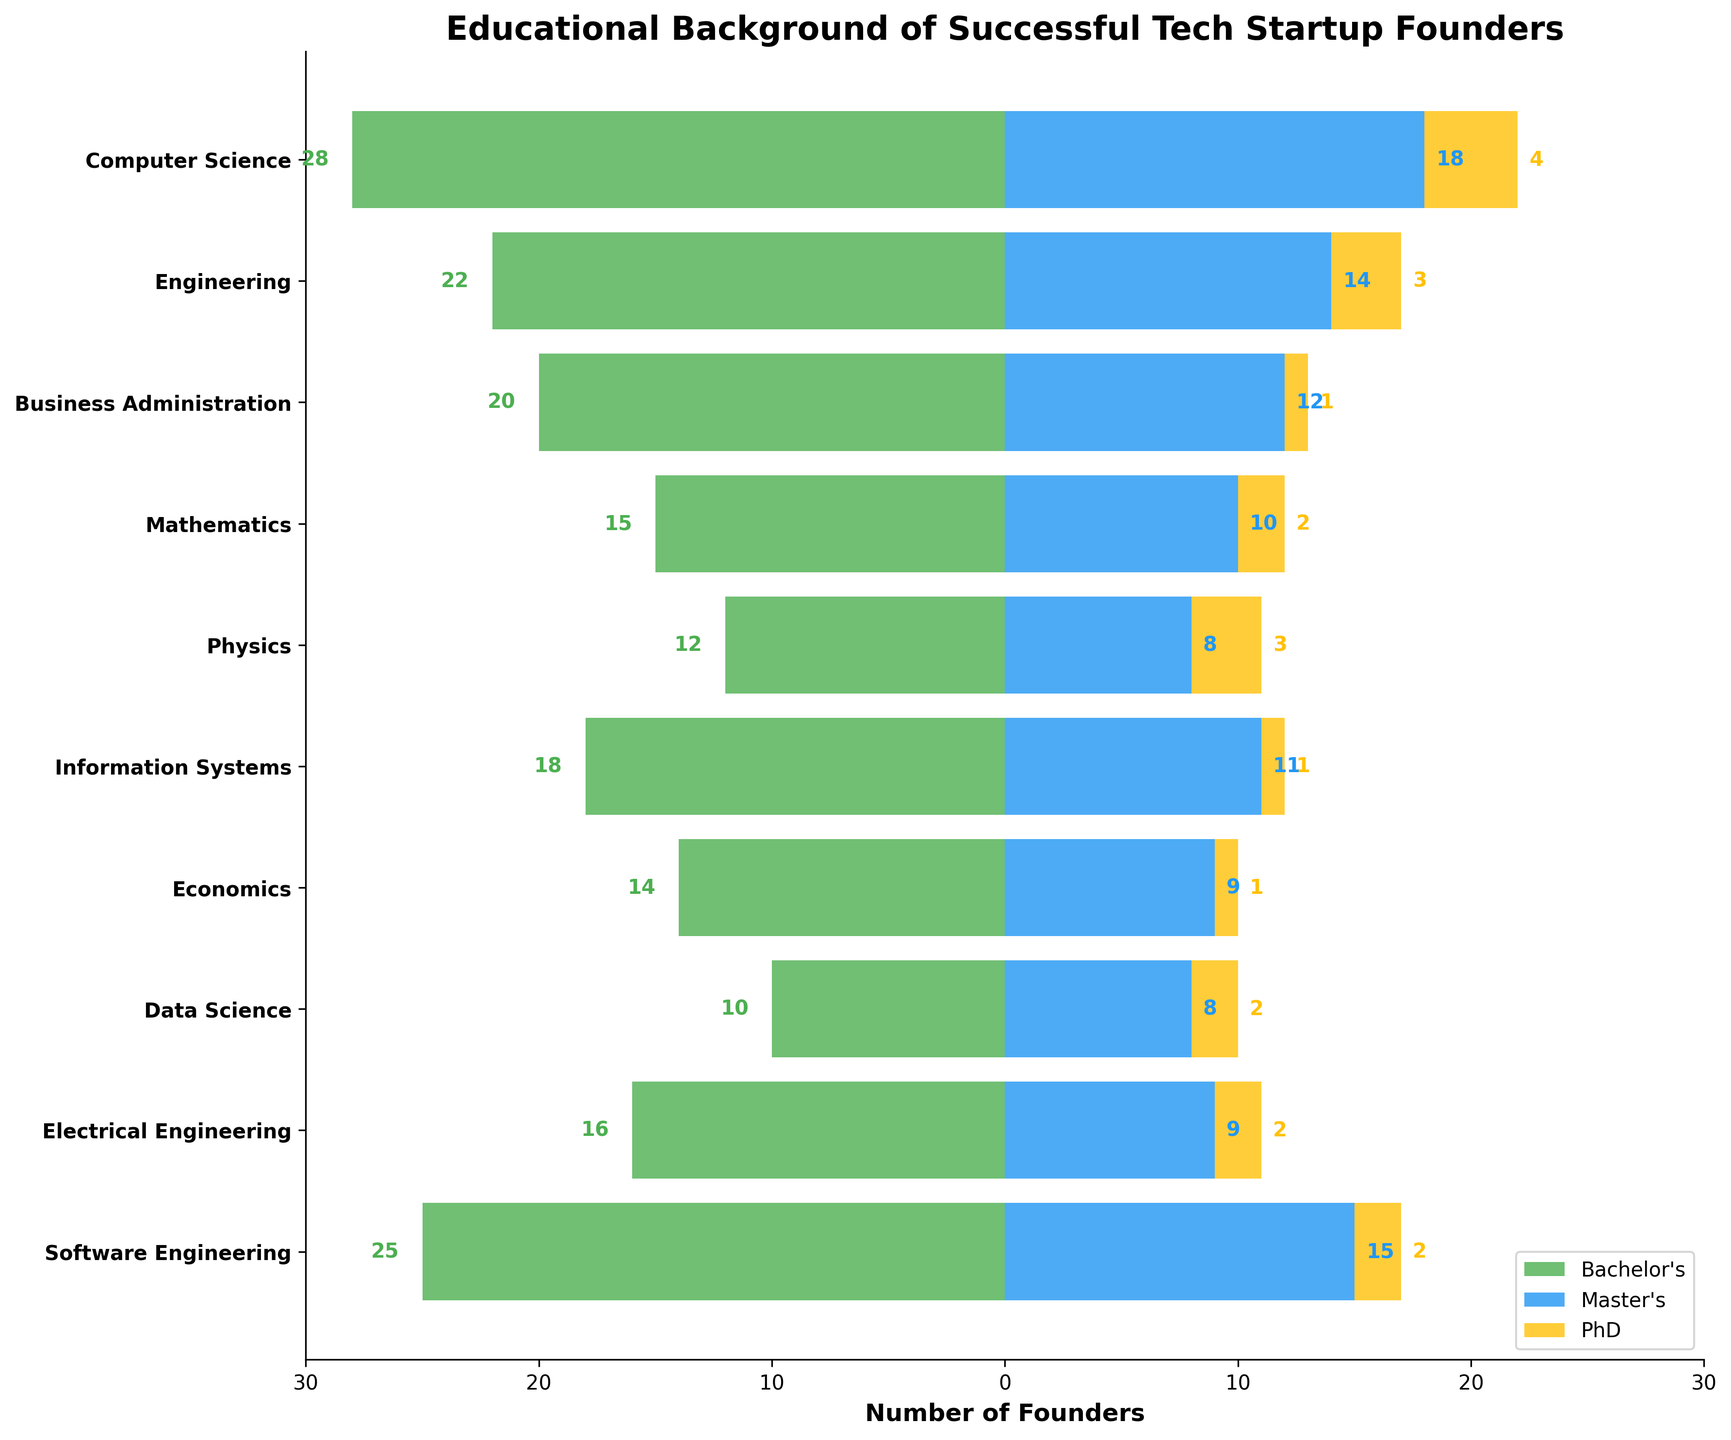Which field of study has the highest number of founders with Bachelor's degrees? By looking at the height of the green bars on the left side of the plot, we can see that the Computer Science field has the highest number (28) of founders with Bachelor's degrees.
Answer: Computer Science Which fields of study have the same number of PhD graduates? By examining the yellow bars, we can see that Engineering, Physics, Electrical Engineering, and Data Science each have 2-3 PhD graduates.
Answer: Engineering, Physics, Electrical Engineering, Data Science What is the total number of founders with Master's degrees in Engineering and Business Administration combined? By looking at the blue bars, Engineering has 14 founders with Master's degrees and Business Administration has 12. Adding these together gives 14 + 12 = 26.
Answer: 26 How many more founders with Bachelor's degrees are there in Software Engineering compared to Data Science? From the green bars, Software Engineering has 25 founders with Bachelor's degrees, while Data Science has 10. The difference is 25 - 10 = 15.
Answer: 15 Which field of study has the least number of founders with a PhD degree? By evaluating the height of the yellow bars, Business Administration, Information Systems, and Economics each have only 1 founder with a PhD degree.
Answer: Business Administration, Information Systems, Economics What is the difference in the number of founders with Master's degrees in Computer Science compared to Information Systems? Computer Science has 18 founders with Master's degrees and Information Systems has 11. Therefore, the difference is 18 - 11 = 7.
Answer: 7 How many founder's educational backgrounds in Computer Science include either a Master's degree or a PhD? Looking at the blue and yellow bars for Computer Science, there are 18 founders with Master's and 4 with PhDs. The total is 18 + 4 = 22.
Answer: 22 Between Mathematics and Physics, which field has more founders with Bachelor's and Master's degrees combined? Mathematics has 15 Bachelor's and 10 Master's degree holders (total 25), while Physics has 12 Bachelor's and 8 Master's degree holders (total 20). Therefore, Mathematics has more.
Answer: Mathematics 